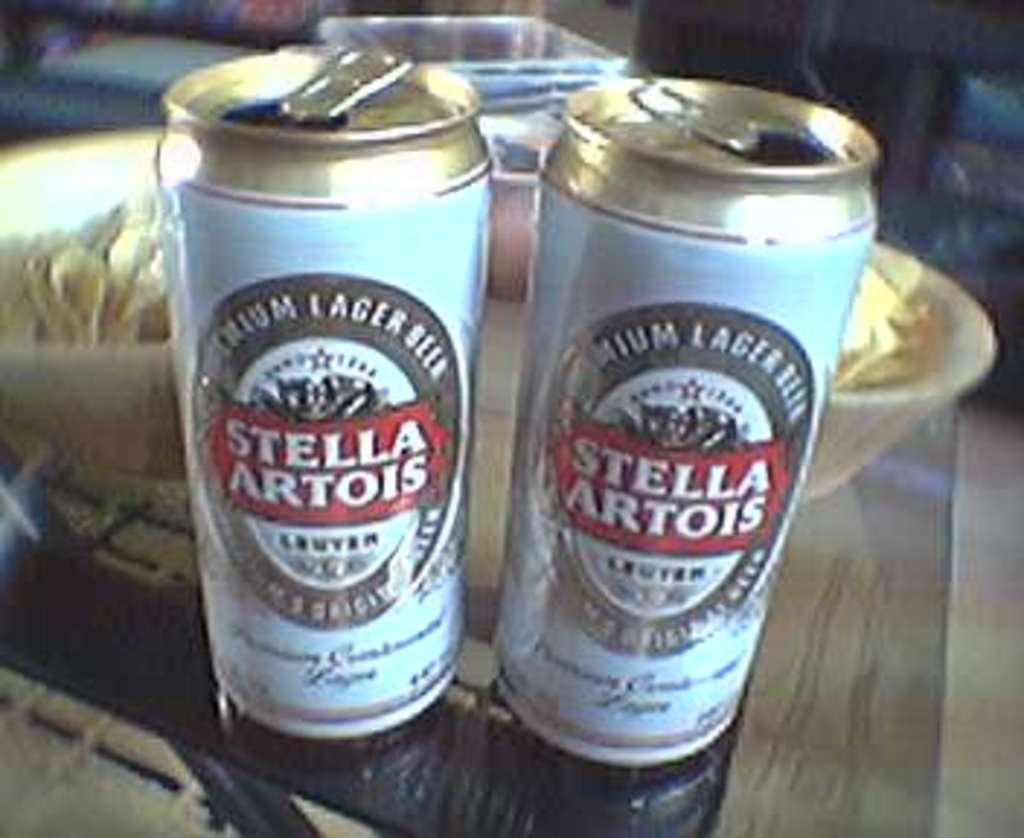<image>
Share a concise interpretation of the image provided. Two open cans of Stella on a table in front of a bowl. 